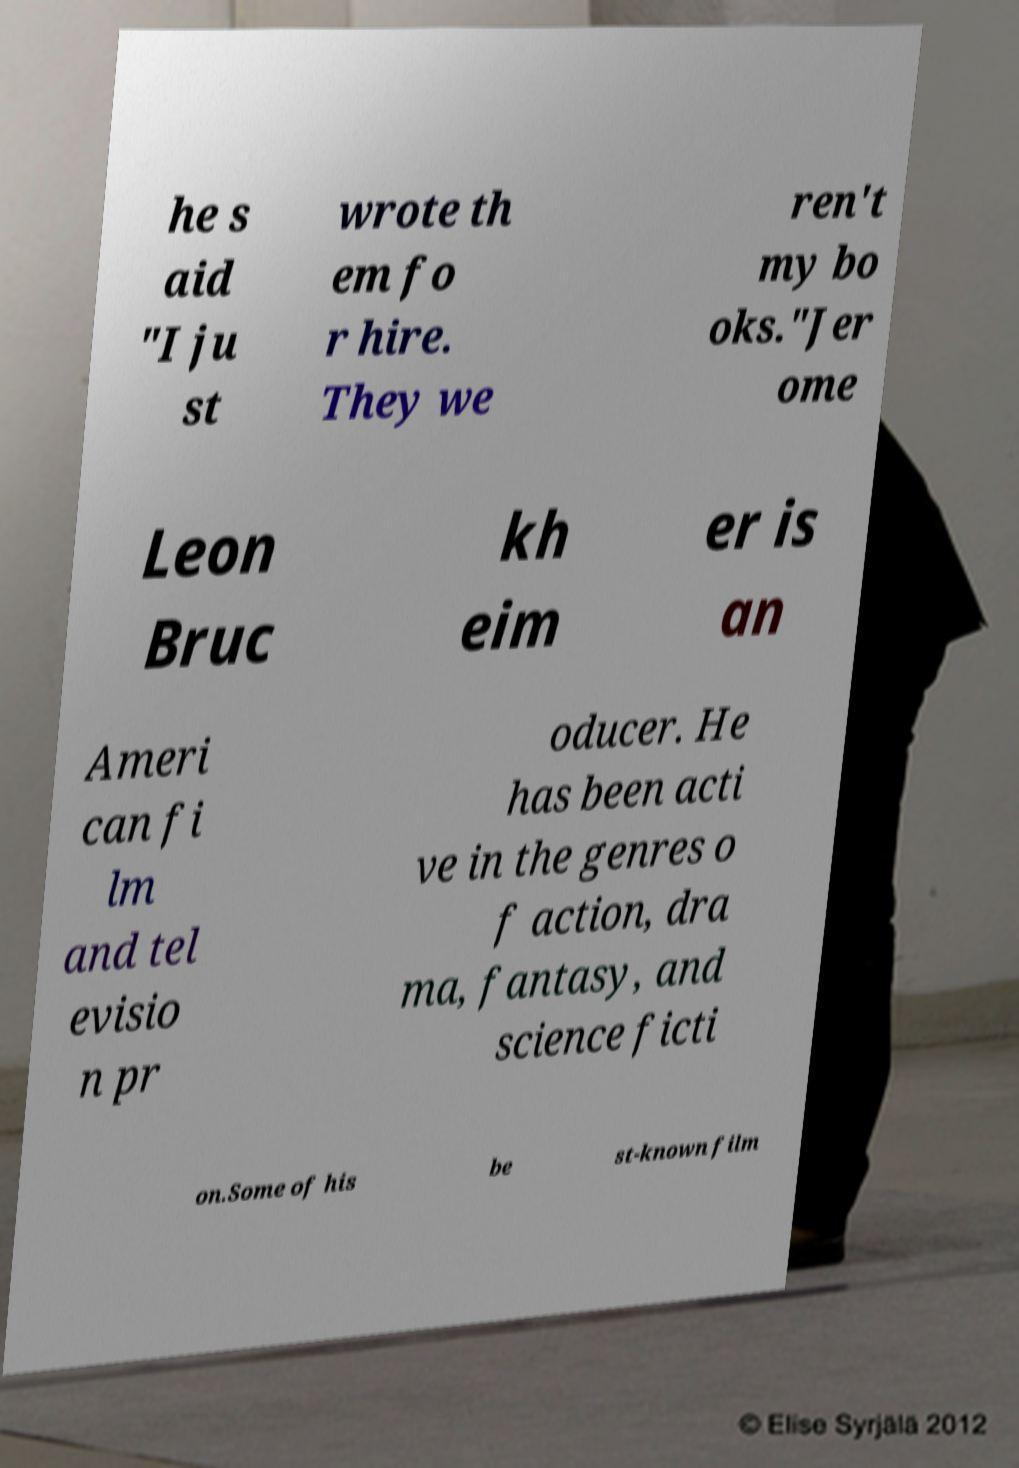Please identify and transcribe the text found in this image. he s aid "I ju st wrote th em fo r hire. They we ren't my bo oks."Jer ome Leon Bruc kh eim er is an Ameri can fi lm and tel evisio n pr oducer. He has been acti ve in the genres o f action, dra ma, fantasy, and science ficti on.Some of his be st-known film 